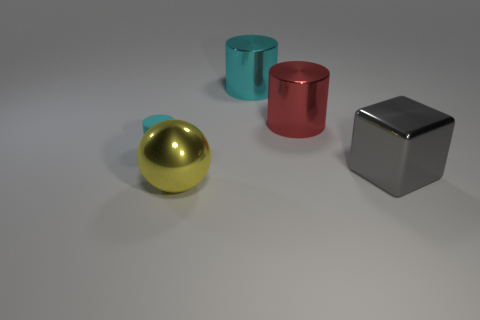Are there any other things that are the same size as the cyan matte cylinder?
Ensure brevity in your answer.  No. The big yellow shiny object has what shape?
Ensure brevity in your answer.  Sphere. What is the size of the cyan cylinder that is behind the cyan rubber cylinder?
Your answer should be very brief. Large. What color is the cylinder that is the same size as the cyan shiny object?
Provide a succinct answer. Red. Is there a large metallic cylinder of the same color as the small object?
Give a very brief answer. Yes. Is the number of small cylinders right of the yellow object less than the number of red metallic objects behind the gray metal object?
Ensure brevity in your answer.  Yes. There is a big object that is both on the right side of the yellow metallic ball and on the left side of the large red shiny cylinder; what is its material?
Keep it short and to the point. Metal. There is a cyan rubber object; is its shape the same as the cyan thing that is behind the small rubber thing?
Give a very brief answer. Yes. How many other things are there of the same size as the shiny cube?
Make the answer very short. 3. Is the number of yellow metallic blocks greater than the number of metallic balls?
Offer a terse response. No. 